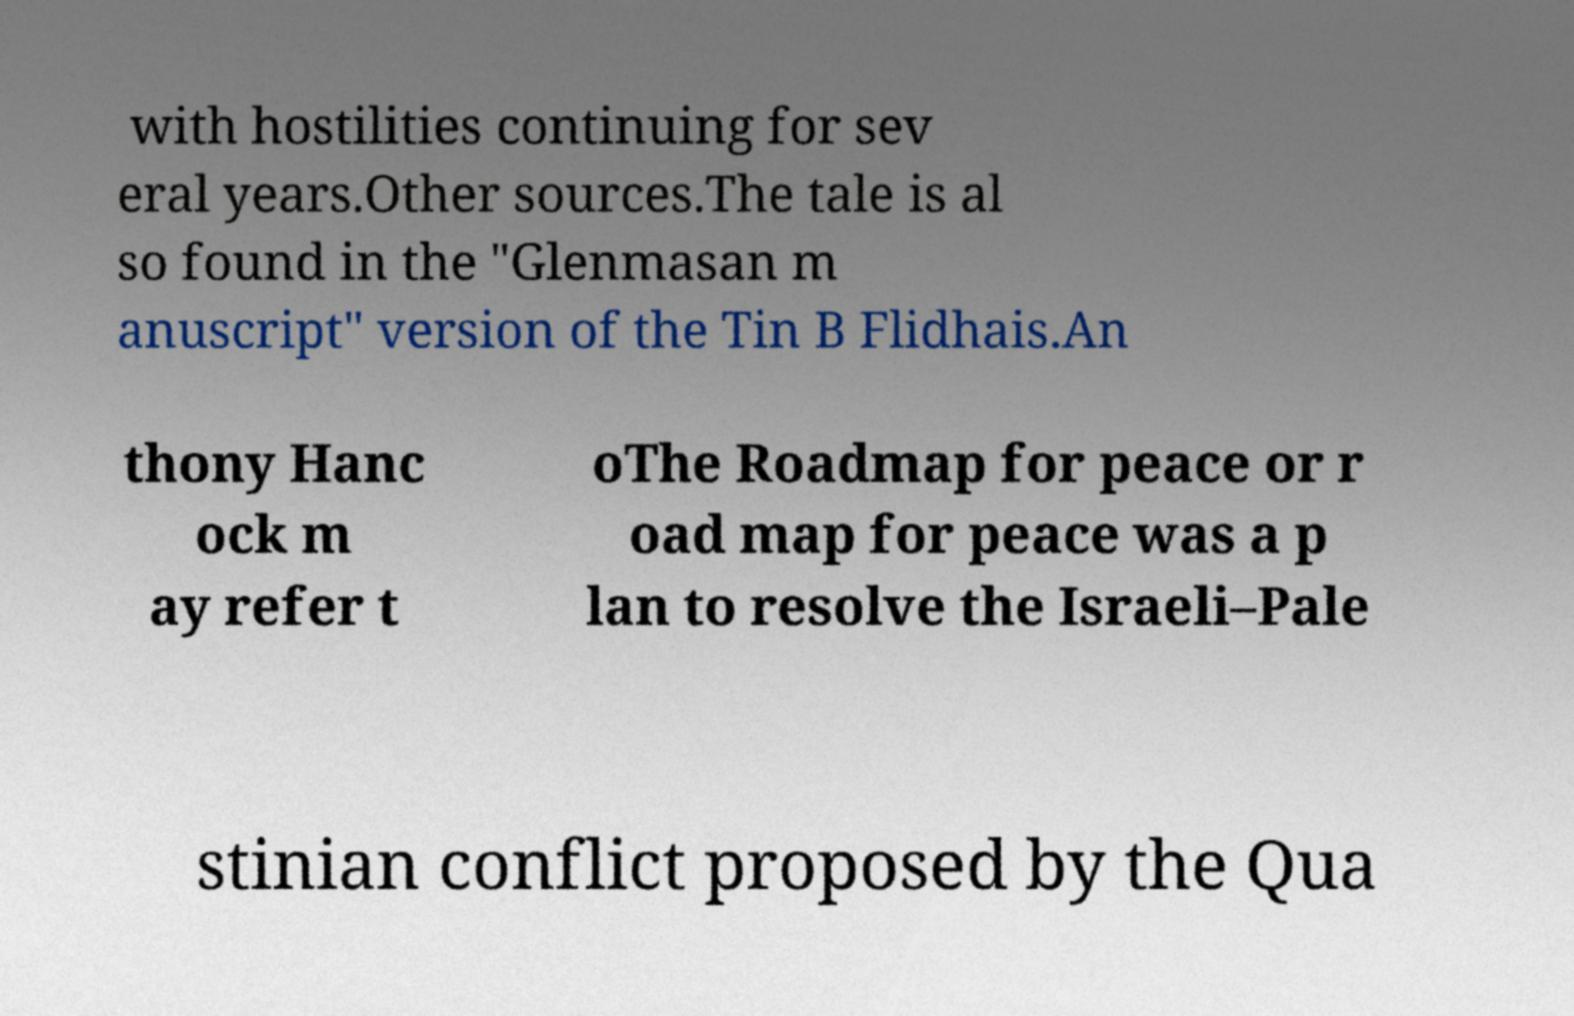What messages or text are displayed in this image? I need them in a readable, typed format. with hostilities continuing for sev eral years.Other sources.The tale is al so found in the "Glenmasan m anuscript" version of the Tin B Flidhais.An thony Hanc ock m ay refer t oThe Roadmap for peace or r oad map for peace was a p lan to resolve the Israeli–Pale stinian conflict proposed by the Qua 